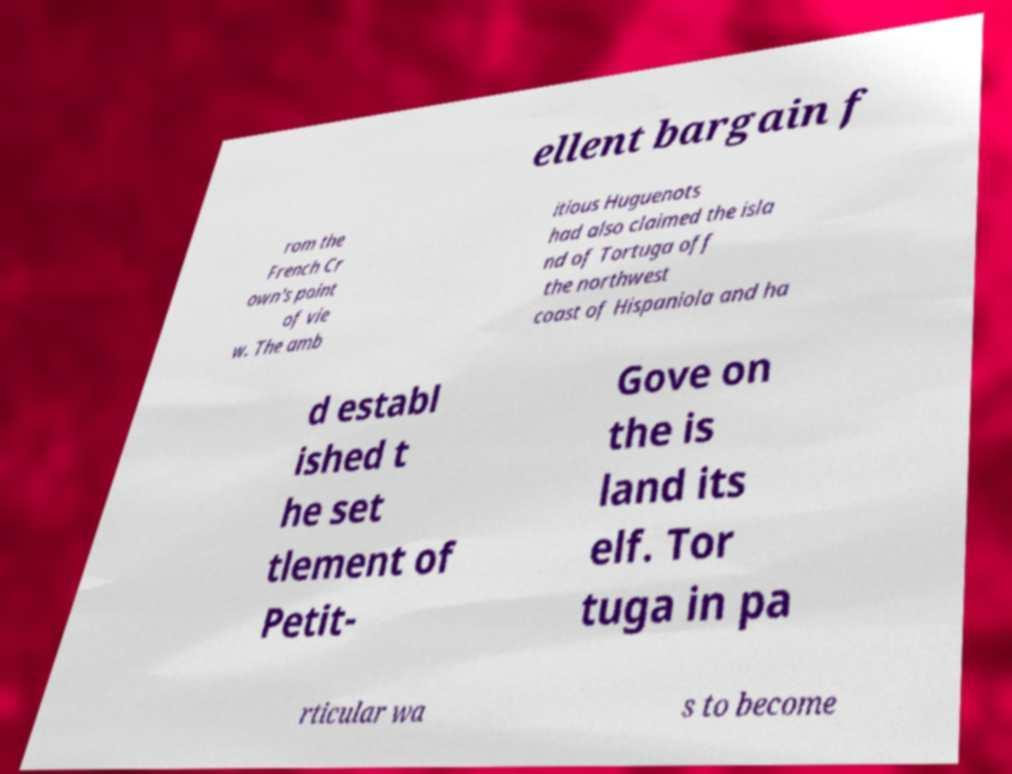Could you extract and type out the text from this image? ellent bargain f rom the French Cr own's point of vie w. The amb itious Huguenots had also claimed the isla nd of Tortuga off the northwest coast of Hispaniola and ha d establ ished t he set tlement of Petit- Gove on the is land its elf. Tor tuga in pa rticular wa s to become 